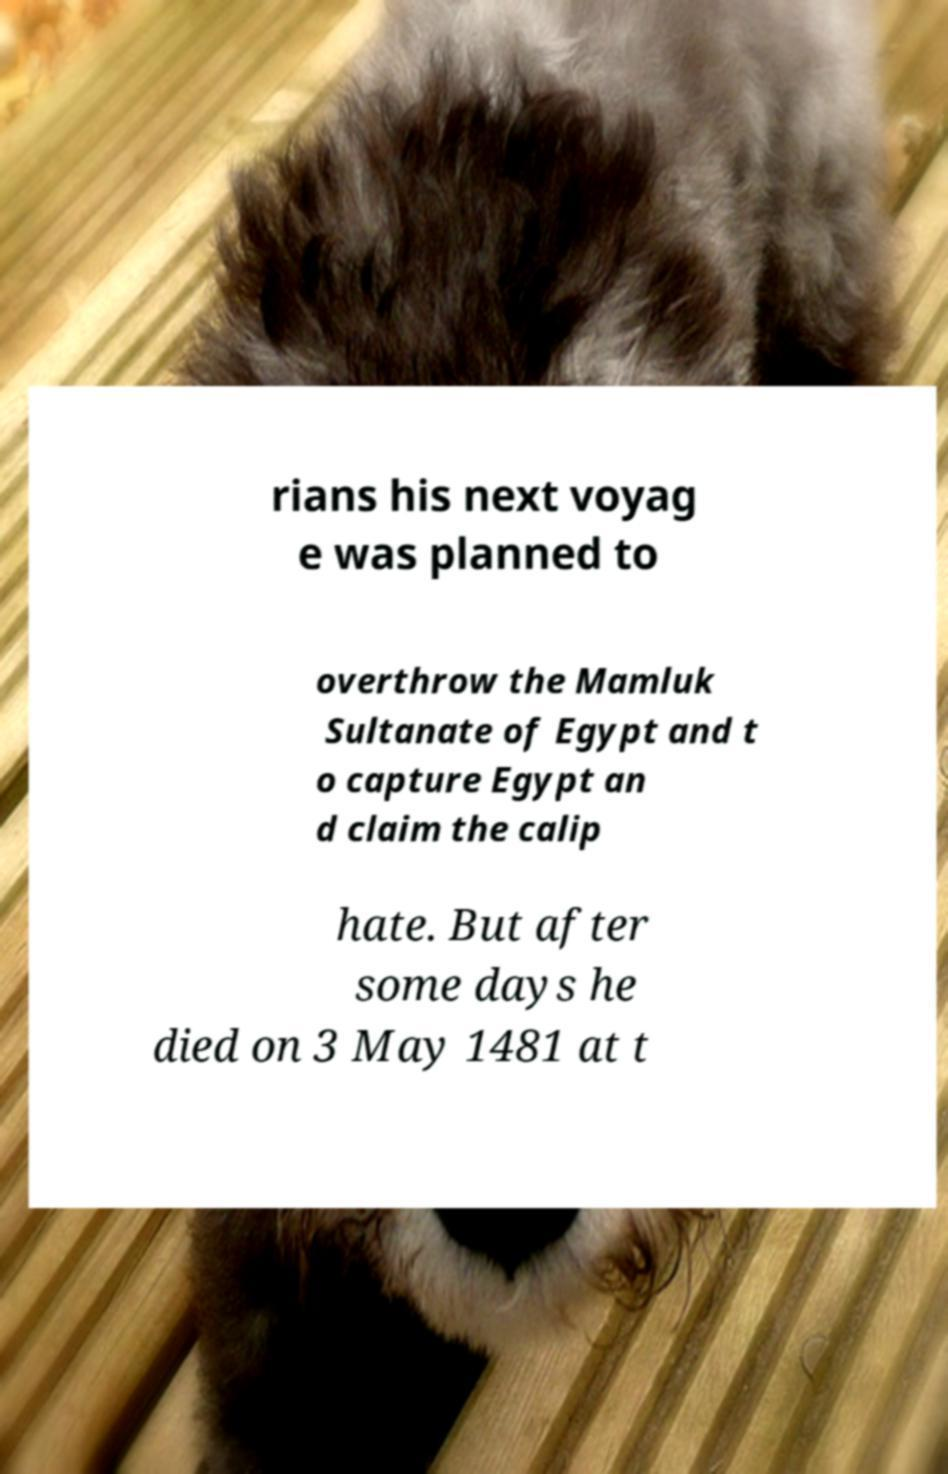Could you extract and type out the text from this image? rians his next voyag e was planned to overthrow the Mamluk Sultanate of Egypt and t o capture Egypt an d claim the calip hate. But after some days he died on 3 May 1481 at t 